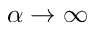Convert formula to latex. <formula><loc_0><loc_0><loc_500><loc_500>\alpha \rightarrow \infty</formula> 